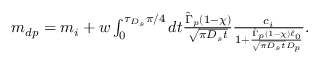Convert formula to latex. <formula><loc_0><loc_0><loc_500><loc_500>\begin{array} { r } { m _ { d p } = m _ { i } + w \int _ { 0 } ^ { \tau _ { D _ { s } } \pi / 4 } d t \frac { \hat { \Gamma } _ { p } ( 1 - \chi ) } { \sqrt { \pi D _ { s } t } } \frac { c _ { i } } { 1 + \frac { \hat { \Gamma } _ { p } ( 1 - \chi ) \ell _ { 0 } } { \sqrt { \pi D _ { s } t } D _ { p } } } . } \end{array}</formula> 